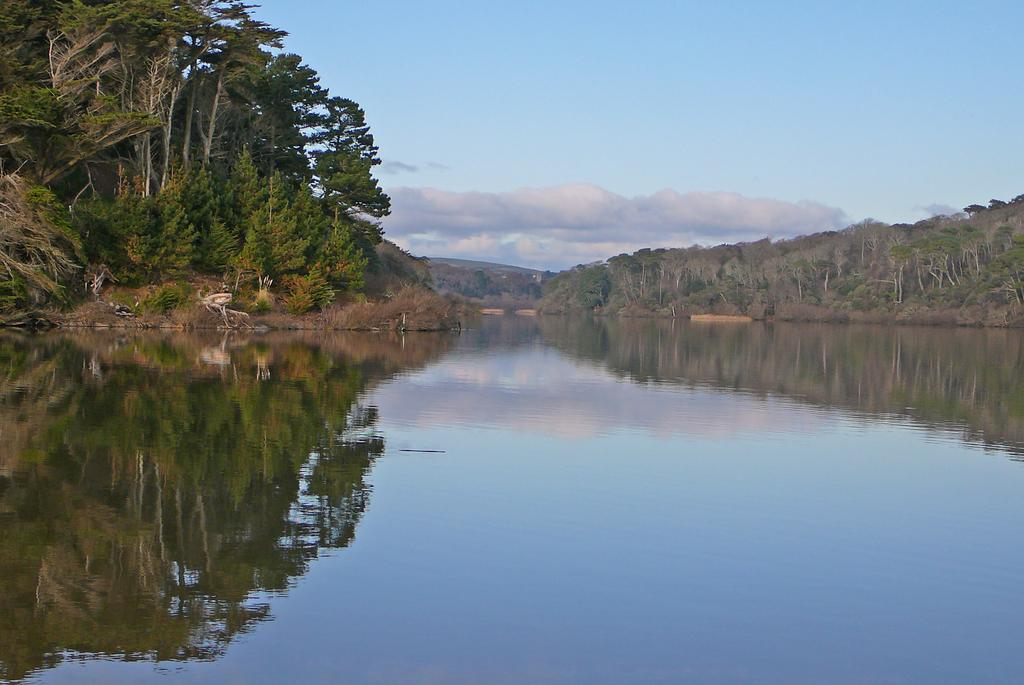What is visible in the image? Water, trees, and a hill are visible in the image. What is the condition of the sky in the image? The sky is cloudy in the image. What news is being reported by the duck in the image? There is no duck present in the image, and therefore no news can be reported. What time of day is it in the image, considering the presence of the morning? The provided facts do not mention the time of day or the presence of morning, so it cannot be determined from the image. 